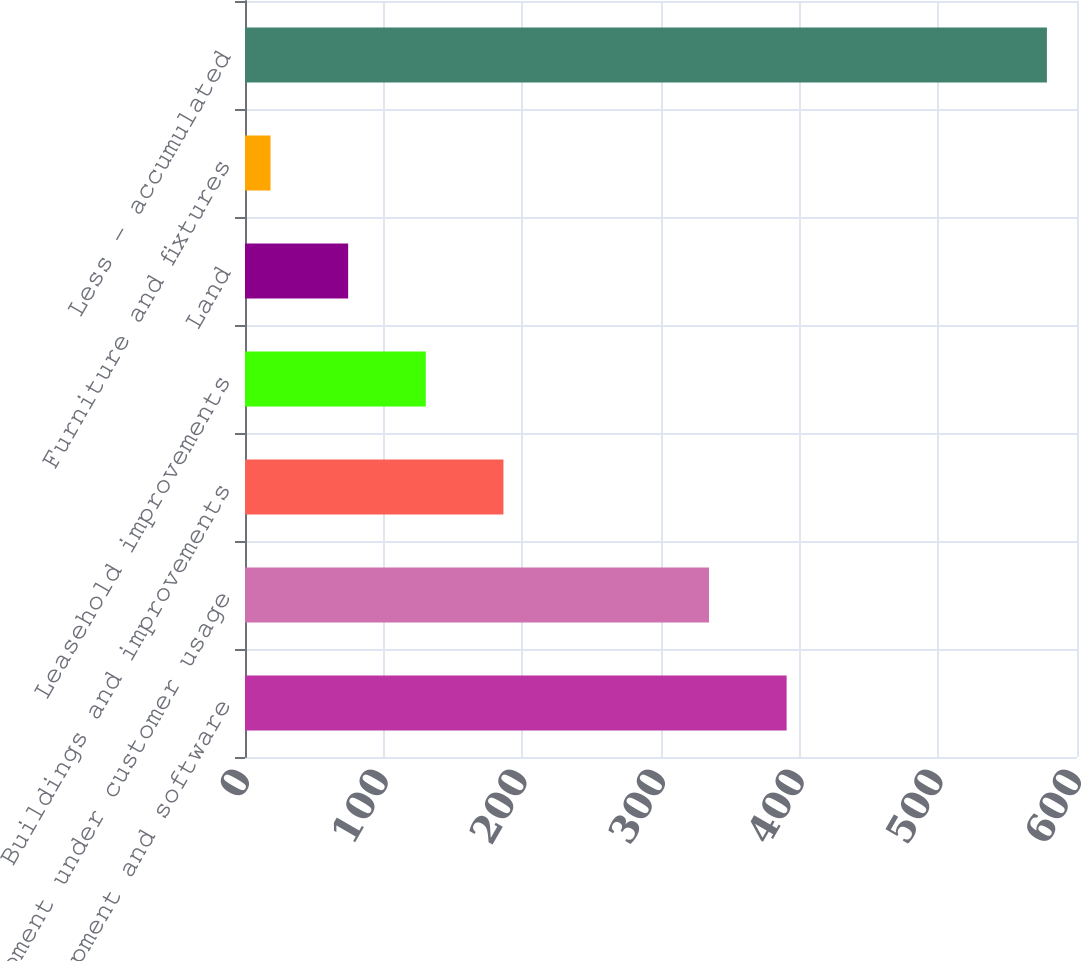Convert chart. <chart><loc_0><loc_0><loc_500><loc_500><bar_chart><fcel>Equipment and software<fcel>Equipment under customer usage<fcel>Buildings and improvements<fcel>Leasehold improvements<fcel>Land<fcel>Furniture and fixtures<fcel>Less - accumulated<nl><fcel>390.59<fcel>334.6<fcel>186.37<fcel>130.38<fcel>74.39<fcel>18.4<fcel>578.3<nl></chart> 